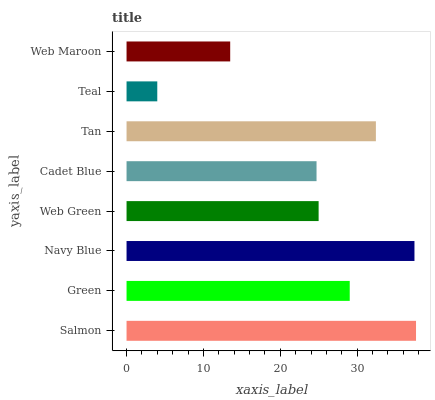Is Teal the minimum?
Answer yes or no. Yes. Is Salmon the maximum?
Answer yes or no. Yes. Is Green the minimum?
Answer yes or no. No. Is Green the maximum?
Answer yes or no. No. Is Salmon greater than Green?
Answer yes or no. Yes. Is Green less than Salmon?
Answer yes or no. Yes. Is Green greater than Salmon?
Answer yes or no. No. Is Salmon less than Green?
Answer yes or no. No. Is Green the high median?
Answer yes or no. Yes. Is Web Green the low median?
Answer yes or no. Yes. Is Tan the high median?
Answer yes or no. No. Is Salmon the low median?
Answer yes or no. No. 